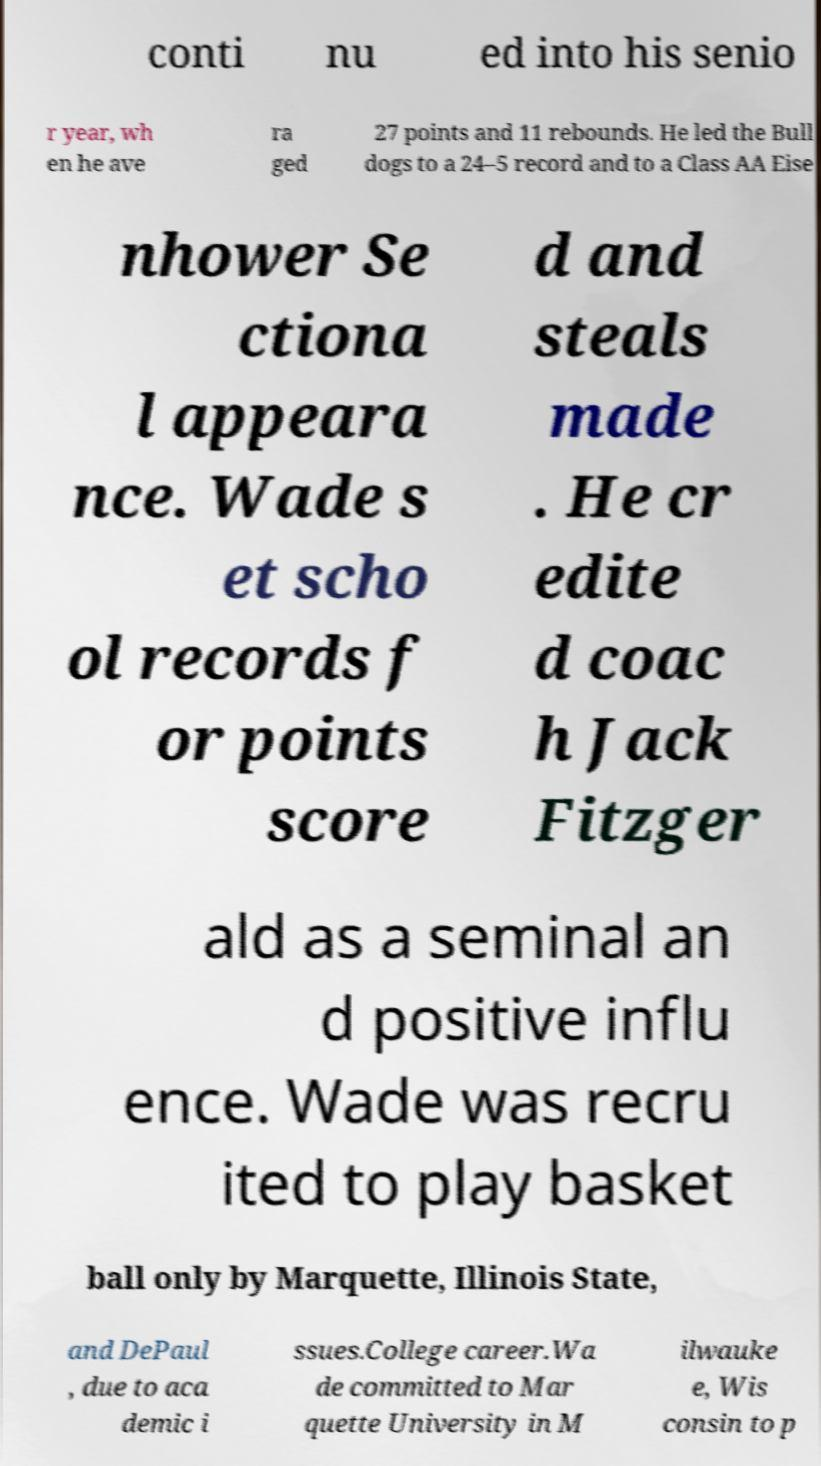There's text embedded in this image that I need extracted. Can you transcribe it verbatim? conti nu ed into his senio r year, wh en he ave ra ged 27 points and 11 rebounds. He led the Bull dogs to a 24–5 record and to a Class AA Eise nhower Se ctiona l appeara nce. Wade s et scho ol records f or points score d and steals made . He cr edite d coac h Jack Fitzger ald as a seminal an d positive influ ence. Wade was recru ited to play basket ball only by Marquette, Illinois State, and DePaul , due to aca demic i ssues.College career.Wa de committed to Mar quette University in M ilwauke e, Wis consin to p 